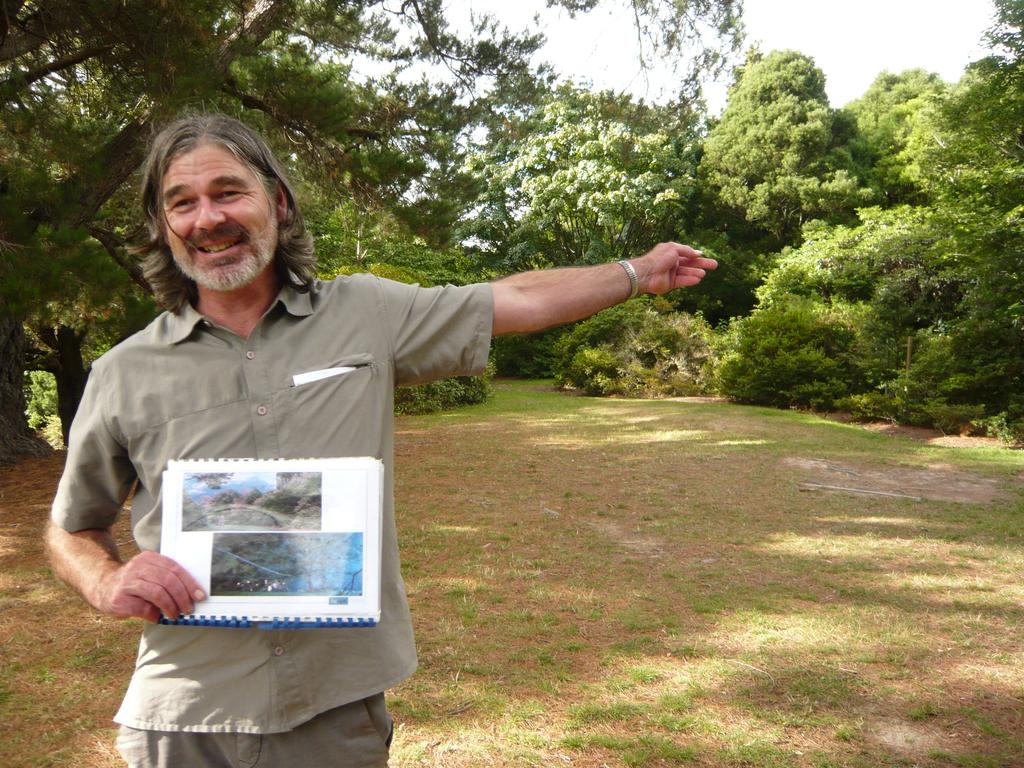What is the person on the left side of the image doing? The person is standing on the left side of the image and holding some books. What type of surface is visible at the bottom of the image? There is grass and sand at the bottom of the image. What can be seen in the background of the image? There are trees in the background of the image. How many members are on the boy's team in the image? There is no boy or team present in the image. What type of tools does the carpenter have in the image? There is no carpenter or tools present in the image. 